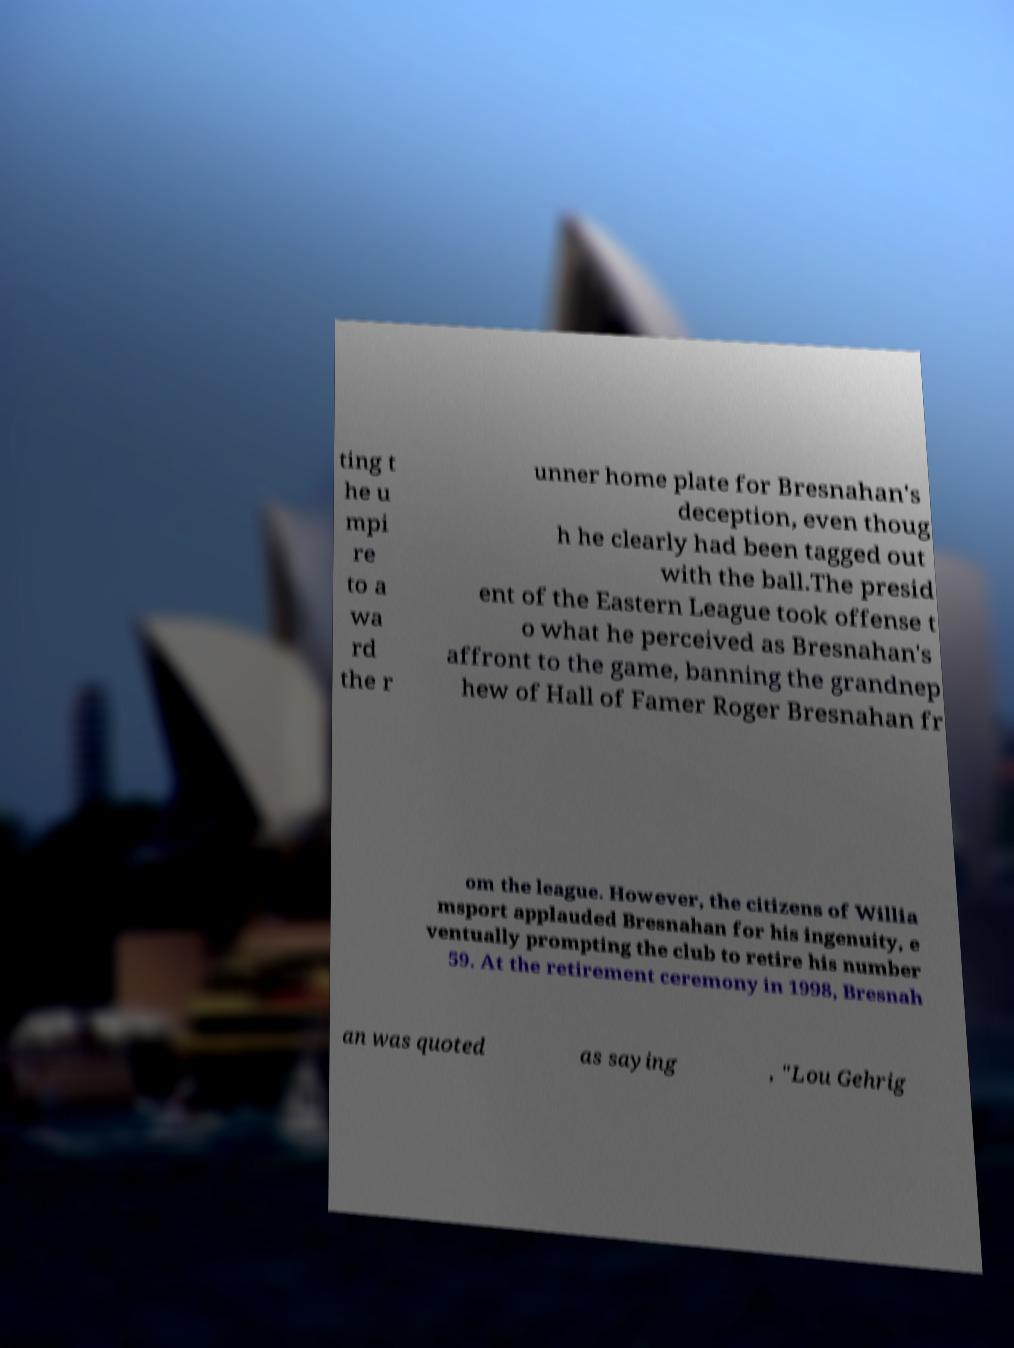Can you read and provide the text displayed in the image?This photo seems to have some interesting text. Can you extract and type it out for me? ting t he u mpi re to a wa rd the r unner home plate for Bresnahan's deception, even thoug h he clearly had been tagged out with the ball.The presid ent of the Eastern League took offense t o what he perceived as Bresnahan's affront to the game, banning the grandnep hew of Hall of Famer Roger Bresnahan fr om the league. However, the citizens of Willia msport applauded Bresnahan for his ingenuity, e ventually prompting the club to retire his number 59. At the retirement ceremony in 1998, Bresnah an was quoted as saying , "Lou Gehrig 